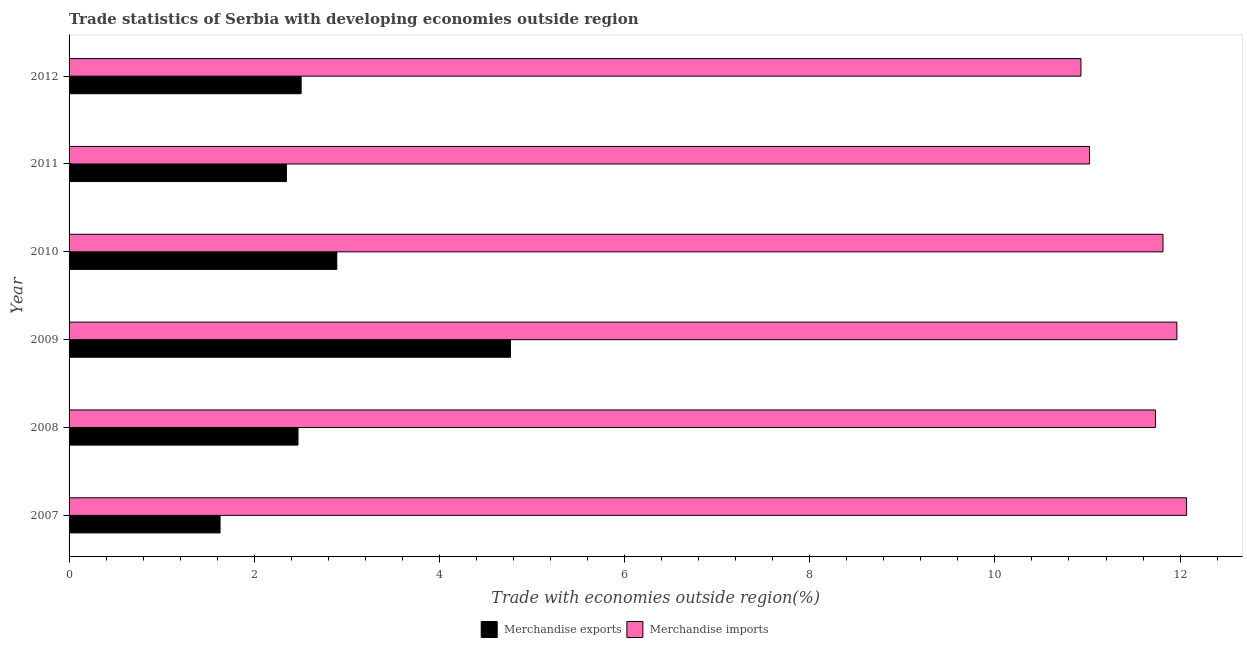Are the number of bars on each tick of the Y-axis equal?
Ensure brevity in your answer.  Yes. How many bars are there on the 1st tick from the top?
Make the answer very short. 2. What is the label of the 6th group of bars from the top?
Provide a short and direct response. 2007. In how many cases, is the number of bars for a given year not equal to the number of legend labels?
Your answer should be compact. 0. What is the merchandise imports in 2007?
Your answer should be very brief. 12.07. Across all years, what is the maximum merchandise imports?
Your answer should be compact. 12.07. Across all years, what is the minimum merchandise exports?
Offer a terse response. 1.63. What is the total merchandise imports in the graph?
Your answer should be compact. 69.54. What is the difference between the merchandise exports in 2010 and that in 2011?
Your response must be concise. 0.54. What is the difference between the merchandise imports in 2008 and the merchandise exports in 2011?
Make the answer very short. 9.39. What is the average merchandise imports per year?
Provide a short and direct response. 11.59. In the year 2011, what is the difference between the merchandise exports and merchandise imports?
Offer a very short reply. -8.67. What is the ratio of the merchandise exports in 2007 to that in 2011?
Make the answer very short. 0.69. What is the difference between the highest and the second highest merchandise exports?
Provide a short and direct response. 1.88. What is the difference between the highest and the lowest merchandise exports?
Offer a very short reply. 3.14. In how many years, is the merchandise imports greater than the average merchandise imports taken over all years?
Give a very brief answer. 4. What does the 1st bar from the top in 2011 represents?
Your answer should be very brief. Merchandise imports. What does the 1st bar from the bottom in 2008 represents?
Offer a very short reply. Merchandise exports. How many bars are there?
Offer a terse response. 12. Are all the bars in the graph horizontal?
Offer a terse response. Yes. How many years are there in the graph?
Your answer should be compact. 6. What is the difference between two consecutive major ticks on the X-axis?
Your answer should be compact. 2. Are the values on the major ticks of X-axis written in scientific E-notation?
Offer a terse response. No. Does the graph contain any zero values?
Keep it short and to the point. No. Does the graph contain grids?
Your answer should be compact. No. Where does the legend appear in the graph?
Give a very brief answer. Bottom center. How are the legend labels stacked?
Provide a succinct answer. Horizontal. What is the title of the graph?
Offer a very short reply. Trade statistics of Serbia with developing economies outside region. Does "Female entrants" appear as one of the legend labels in the graph?
Offer a terse response. No. What is the label or title of the X-axis?
Offer a terse response. Trade with economies outside region(%). What is the label or title of the Y-axis?
Provide a succinct answer. Year. What is the Trade with economies outside region(%) in Merchandise exports in 2007?
Your answer should be very brief. 1.63. What is the Trade with economies outside region(%) in Merchandise imports in 2007?
Your response must be concise. 12.07. What is the Trade with economies outside region(%) in Merchandise exports in 2008?
Offer a terse response. 2.47. What is the Trade with economies outside region(%) in Merchandise imports in 2008?
Offer a very short reply. 11.73. What is the Trade with economies outside region(%) of Merchandise exports in 2009?
Keep it short and to the point. 4.77. What is the Trade with economies outside region(%) in Merchandise imports in 2009?
Give a very brief answer. 11.97. What is the Trade with economies outside region(%) of Merchandise exports in 2010?
Offer a very short reply. 2.89. What is the Trade with economies outside region(%) of Merchandise imports in 2010?
Offer a terse response. 11.82. What is the Trade with economies outside region(%) in Merchandise exports in 2011?
Provide a short and direct response. 2.35. What is the Trade with economies outside region(%) of Merchandise imports in 2011?
Give a very brief answer. 11.02. What is the Trade with economies outside region(%) of Merchandise exports in 2012?
Provide a short and direct response. 2.51. What is the Trade with economies outside region(%) of Merchandise imports in 2012?
Your answer should be very brief. 10.93. Across all years, what is the maximum Trade with economies outside region(%) in Merchandise exports?
Keep it short and to the point. 4.77. Across all years, what is the maximum Trade with economies outside region(%) in Merchandise imports?
Keep it short and to the point. 12.07. Across all years, what is the minimum Trade with economies outside region(%) in Merchandise exports?
Keep it short and to the point. 1.63. Across all years, what is the minimum Trade with economies outside region(%) of Merchandise imports?
Ensure brevity in your answer.  10.93. What is the total Trade with economies outside region(%) in Merchandise exports in the graph?
Offer a very short reply. 16.62. What is the total Trade with economies outside region(%) in Merchandise imports in the graph?
Offer a very short reply. 69.54. What is the difference between the Trade with economies outside region(%) of Merchandise exports in 2007 and that in 2008?
Your response must be concise. -0.84. What is the difference between the Trade with economies outside region(%) of Merchandise imports in 2007 and that in 2008?
Make the answer very short. 0.34. What is the difference between the Trade with economies outside region(%) in Merchandise exports in 2007 and that in 2009?
Offer a terse response. -3.14. What is the difference between the Trade with economies outside region(%) of Merchandise imports in 2007 and that in 2009?
Make the answer very short. 0.11. What is the difference between the Trade with economies outside region(%) in Merchandise exports in 2007 and that in 2010?
Give a very brief answer. -1.26. What is the difference between the Trade with economies outside region(%) of Merchandise imports in 2007 and that in 2010?
Provide a short and direct response. 0.26. What is the difference between the Trade with economies outside region(%) of Merchandise exports in 2007 and that in 2011?
Your answer should be compact. -0.72. What is the difference between the Trade with economies outside region(%) in Merchandise imports in 2007 and that in 2011?
Keep it short and to the point. 1.05. What is the difference between the Trade with economies outside region(%) in Merchandise exports in 2007 and that in 2012?
Give a very brief answer. -0.88. What is the difference between the Trade with economies outside region(%) in Merchandise imports in 2007 and that in 2012?
Your answer should be compact. 1.14. What is the difference between the Trade with economies outside region(%) of Merchandise exports in 2008 and that in 2009?
Your answer should be compact. -2.29. What is the difference between the Trade with economies outside region(%) of Merchandise imports in 2008 and that in 2009?
Give a very brief answer. -0.23. What is the difference between the Trade with economies outside region(%) of Merchandise exports in 2008 and that in 2010?
Your response must be concise. -0.42. What is the difference between the Trade with economies outside region(%) of Merchandise imports in 2008 and that in 2010?
Keep it short and to the point. -0.08. What is the difference between the Trade with economies outside region(%) in Merchandise exports in 2008 and that in 2011?
Ensure brevity in your answer.  0.13. What is the difference between the Trade with economies outside region(%) of Merchandise imports in 2008 and that in 2011?
Your answer should be very brief. 0.71. What is the difference between the Trade with economies outside region(%) in Merchandise exports in 2008 and that in 2012?
Make the answer very short. -0.03. What is the difference between the Trade with economies outside region(%) of Merchandise imports in 2008 and that in 2012?
Provide a short and direct response. 0.81. What is the difference between the Trade with economies outside region(%) of Merchandise exports in 2009 and that in 2010?
Offer a terse response. 1.88. What is the difference between the Trade with economies outside region(%) in Merchandise imports in 2009 and that in 2010?
Your response must be concise. 0.15. What is the difference between the Trade with economies outside region(%) in Merchandise exports in 2009 and that in 2011?
Offer a very short reply. 2.42. What is the difference between the Trade with economies outside region(%) in Merchandise imports in 2009 and that in 2011?
Offer a terse response. 0.94. What is the difference between the Trade with economies outside region(%) of Merchandise exports in 2009 and that in 2012?
Give a very brief answer. 2.26. What is the difference between the Trade with economies outside region(%) in Merchandise imports in 2009 and that in 2012?
Provide a short and direct response. 1.04. What is the difference between the Trade with economies outside region(%) of Merchandise exports in 2010 and that in 2011?
Your answer should be very brief. 0.54. What is the difference between the Trade with economies outside region(%) of Merchandise imports in 2010 and that in 2011?
Give a very brief answer. 0.79. What is the difference between the Trade with economies outside region(%) in Merchandise exports in 2010 and that in 2012?
Keep it short and to the point. 0.39. What is the difference between the Trade with economies outside region(%) of Merchandise imports in 2010 and that in 2012?
Offer a terse response. 0.89. What is the difference between the Trade with economies outside region(%) in Merchandise exports in 2011 and that in 2012?
Offer a very short reply. -0.16. What is the difference between the Trade with economies outside region(%) in Merchandise imports in 2011 and that in 2012?
Provide a succinct answer. 0.09. What is the difference between the Trade with economies outside region(%) of Merchandise exports in 2007 and the Trade with economies outside region(%) of Merchandise imports in 2008?
Provide a succinct answer. -10.1. What is the difference between the Trade with economies outside region(%) in Merchandise exports in 2007 and the Trade with economies outside region(%) in Merchandise imports in 2009?
Keep it short and to the point. -10.33. What is the difference between the Trade with economies outside region(%) of Merchandise exports in 2007 and the Trade with economies outside region(%) of Merchandise imports in 2010?
Ensure brevity in your answer.  -10.18. What is the difference between the Trade with economies outside region(%) of Merchandise exports in 2007 and the Trade with economies outside region(%) of Merchandise imports in 2011?
Your response must be concise. -9.39. What is the difference between the Trade with economies outside region(%) in Merchandise exports in 2007 and the Trade with economies outside region(%) in Merchandise imports in 2012?
Your response must be concise. -9.3. What is the difference between the Trade with economies outside region(%) of Merchandise exports in 2008 and the Trade with economies outside region(%) of Merchandise imports in 2009?
Ensure brevity in your answer.  -9.49. What is the difference between the Trade with economies outside region(%) of Merchandise exports in 2008 and the Trade with economies outside region(%) of Merchandise imports in 2010?
Ensure brevity in your answer.  -9.34. What is the difference between the Trade with economies outside region(%) in Merchandise exports in 2008 and the Trade with economies outside region(%) in Merchandise imports in 2011?
Give a very brief answer. -8.55. What is the difference between the Trade with economies outside region(%) in Merchandise exports in 2008 and the Trade with economies outside region(%) in Merchandise imports in 2012?
Your answer should be very brief. -8.46. What is the difference between the Trade with economies outside region(%) in Merchandise exports in 2009 and the Trade with economies outside region(%) in Merchandise imports in 2010?
Offer a terse response. -7.05. What is the difference between the Trade with economies outside region(%) in Merchandise exports in 2009 and the Trade with economies outside region(%) in Merchandise imports in 2011?
Provide a short and direct response. -6.25. What is the difference between the Trade with economies outside region(%) in Merchandise exports in 2009 and the Trade with economies outside region(%) in Merchandise imports in 2012?
Your answer should be compact. -6.16. What is the difference between the Trade with economies outside region(%) in Merchandise exports in 2010 and the Trade with economies outside region(%) in Merchandise imports in 2011?
Offer a terse response. -8.13. What is the difference between the Trade with economies outside region(%) in Merchandise exports in 2010 and the Trade with economies outside region(%) in Merchandise imports in 2012?
Make the answer very short. -8.04. What is the difference between the Trade with economies outside region(%) of Merchandise exports in 2011 and the Trade with economies outside region(%) of Merchandise imports in 2012?
Make the answer very short. -8.58. What is the average Trade with economies outside region(%) in Merchandise exports per year?
Your response must be concise. 2.77. What is the average Trade with economies outside region(%) in Merchandise imports per year?
Your answer should be compact. 11.59. In the year 2007, what is the difference between the Trade with economies outside region(%) in Merchandise exports and Trade with economies outside region(%) in Merchandise imports?
Offer a very short reply. -10.44. In the year 2008, what is the difference between the Trade with economies outside region(%) in Merchandise exports and Trade with economies outside region(%) in Merchandise imports?
Provide a short and direct response. -9.26. In the year 2009, what is the difference between the Trade with economies outside region(%) in Merchandise exports and Trade with economies outside region(%) in Merchandise imports?
Provide a succinct answer. -7.2. In the year 2010, what is the difference between the Trade with economies outside region(%) in Merchandise exports and Trade with economies outside region(%) in Merchandise imports?
Your answer should be very brief. -8.92. In the year 2011, what is the difference between the Trade with economies outside region(%) of Merchandise exports and Trade with economies outside region(%) of Merchandise imports?
Ensure brevity in your answer.  -8.67. In the year 2012, what is the difference between the Trade with economies outside region(%) in Merchandise exports and Trade with economies outside region(%) in Merchandise imports?
Offer a very short reply. -8.42. What is the ratio of the Trade with economies outside region(%) in Merchandise exports in 2007 to that in 2008?
Ensure brevity in your answer.  0.66. What is the ratio of the Trade with economies outside region(%) of Merchandise imports in 2007 to that in 2008?
Your answer should be very brief. 1.03. What is the ratio of the Trade with economies outside region(%) in Merchandise exports in 2007 to that in 2009?
Offer a terse response. 0.34. What is the ratio of the Trade with economies outside region(%) in Merchandise imports in 2007 to that in 2009?
Your answer should be compact. 1.01. What is the ratio of the Trade with economies outside region(%) in Merchandise exports in 2007 to that in 2010?
Offer a terse response. 0.56. What is the ratio of the Trade with economies outside region(%) of Merchandise imports in 2007 to that in 2010?
Make the answer very short. 1.02. What is the ratio of the Trade with economies outside region(%) in Merchandise exports in 2007 to that in 2011?
Your response must be concise. 0.69. What is the ratio of the Trade with economies outside region(%) in Merchandise imports in 2007 to that in 2011?
Your answer should be compact. 1.1. What is the ratio of the Trade with economies outside region(%) in Merchandise exports in 2007 to that in 2012?
Your answer should be very brief. 0.65. What is the ratio of the Trade with economies outside region(%) in Merchandise imports in 2007 to that in 2012?
Offer a terse response. 1.1. What is the ratio of the Trade with economies outside region(%) of Merchandise exports in 2008 to that in 2009?
Keep it short and to the point. 0.52. What is the ratio of the Trade with economies outside region(%) of Merchandise imports in 2008 to that in 2009?
Your response must be concise. 0.98. What is the ratio of the Trade with economies outside region(%) in Merchandise exports in 2008 to that in 2010?
Your answer should be compact. 0.86. What is the ratio of the Trade with economies outside region(%) of Merchandise imports in 2008 to that in 2010?
Offer a very short reply. 0.99. What is the ratio of the Trade with economies outside region(%) of Merchandise exports in 2008 to that in 2011?
Provide a short and direct response. 1.05. What is the ratio of the Trade with economies outside region(%) of Merchandise imports in 2008 to that in 2011?
Give a very brief answer. 1.06. What is the ratio of the Trade with economies outside region(%) of Merchandise exports in 2008 to that in 2012?
Provide a short and direct response. 0.99. What is the ratio of the Trade with economies outside region(%) in Merchandise imports in 2008 to that in 2012?
Your answer should be compact. 1.07. What is the ratio of the Trade with economies outside region(%) in Merchandise exports in 2009 to that in 2010?
Your answer should be compact. 1.65. What is the ratio of the Trade with economies outside region(%) in Merchandise imports in 2009 to that in 2010?
Your answer should be compact. 1.01. What is the ratio of the Trade with economies outside region(%) in Merchandise exports in 2009 to that in 2011?
Give a very brief answer. 2.03. What is the ratio of the Trade with economies outside region(%) in Merchandise imports in 2009 to that in 2011?
Your response must be concise. 1.09. What is the ratio of the Trade with economies outside region(%) in Merchandise exports in 2009 to that in 2012?
Ensure brevity in your answer.  1.9. What is the ratio of the Trade with economies outside region(%) in Merchandise imports in 2009 to that in 2012?
Ensure brevity in your answer.  1.09. What is the ratio of the Trade with economies outside region(%) in Merchandise exports in 2010 to that in 2011?
Your response must be concise. 1.23. What is the ratio of the Trade with economies outside region(%) in Merchandise imports in 2010 to that in 2011?
Your answer should be compact. 1.07. What is the ratio of the Trade with economies outside region(%) in Merchandise exports in 2010 to that in 2012?
Your response must be concise. 1.15. What is the ratio of the Trade with economies outside region(%) in Merchandise imports in 2010 to that in 2012?
Ensure brevity in your answer.  1.08. What is the ratio of the Trade with economies outside region(%) of Merchandise exports in 2011 to that in 2012?
Ensure brevity in your answer.  0.94. What is the ratio of the Trade with economies outside region(%) in Merchandise imports in 2011 to that in 2012?
Offer a terse response. 1.01. What is the difference between the highest and the second highest Trade with economies outside region(%) of Merchandise exports?
Your response must be concise. 1.88. What is the difference between the highest and the second highest Trade with economies outside region(%) of Merchandise imports?
Your answer should be compact. 0.11. What is the difference between the highest and the lowest Trade with economies outside region(%) in Merchandise exports?
Make the answer very short. 3.14. What is the difference between the highest and the lowest Trade with economies outside region(%) of Merchandise imports?
Keep it short and to the point. 1.14. 